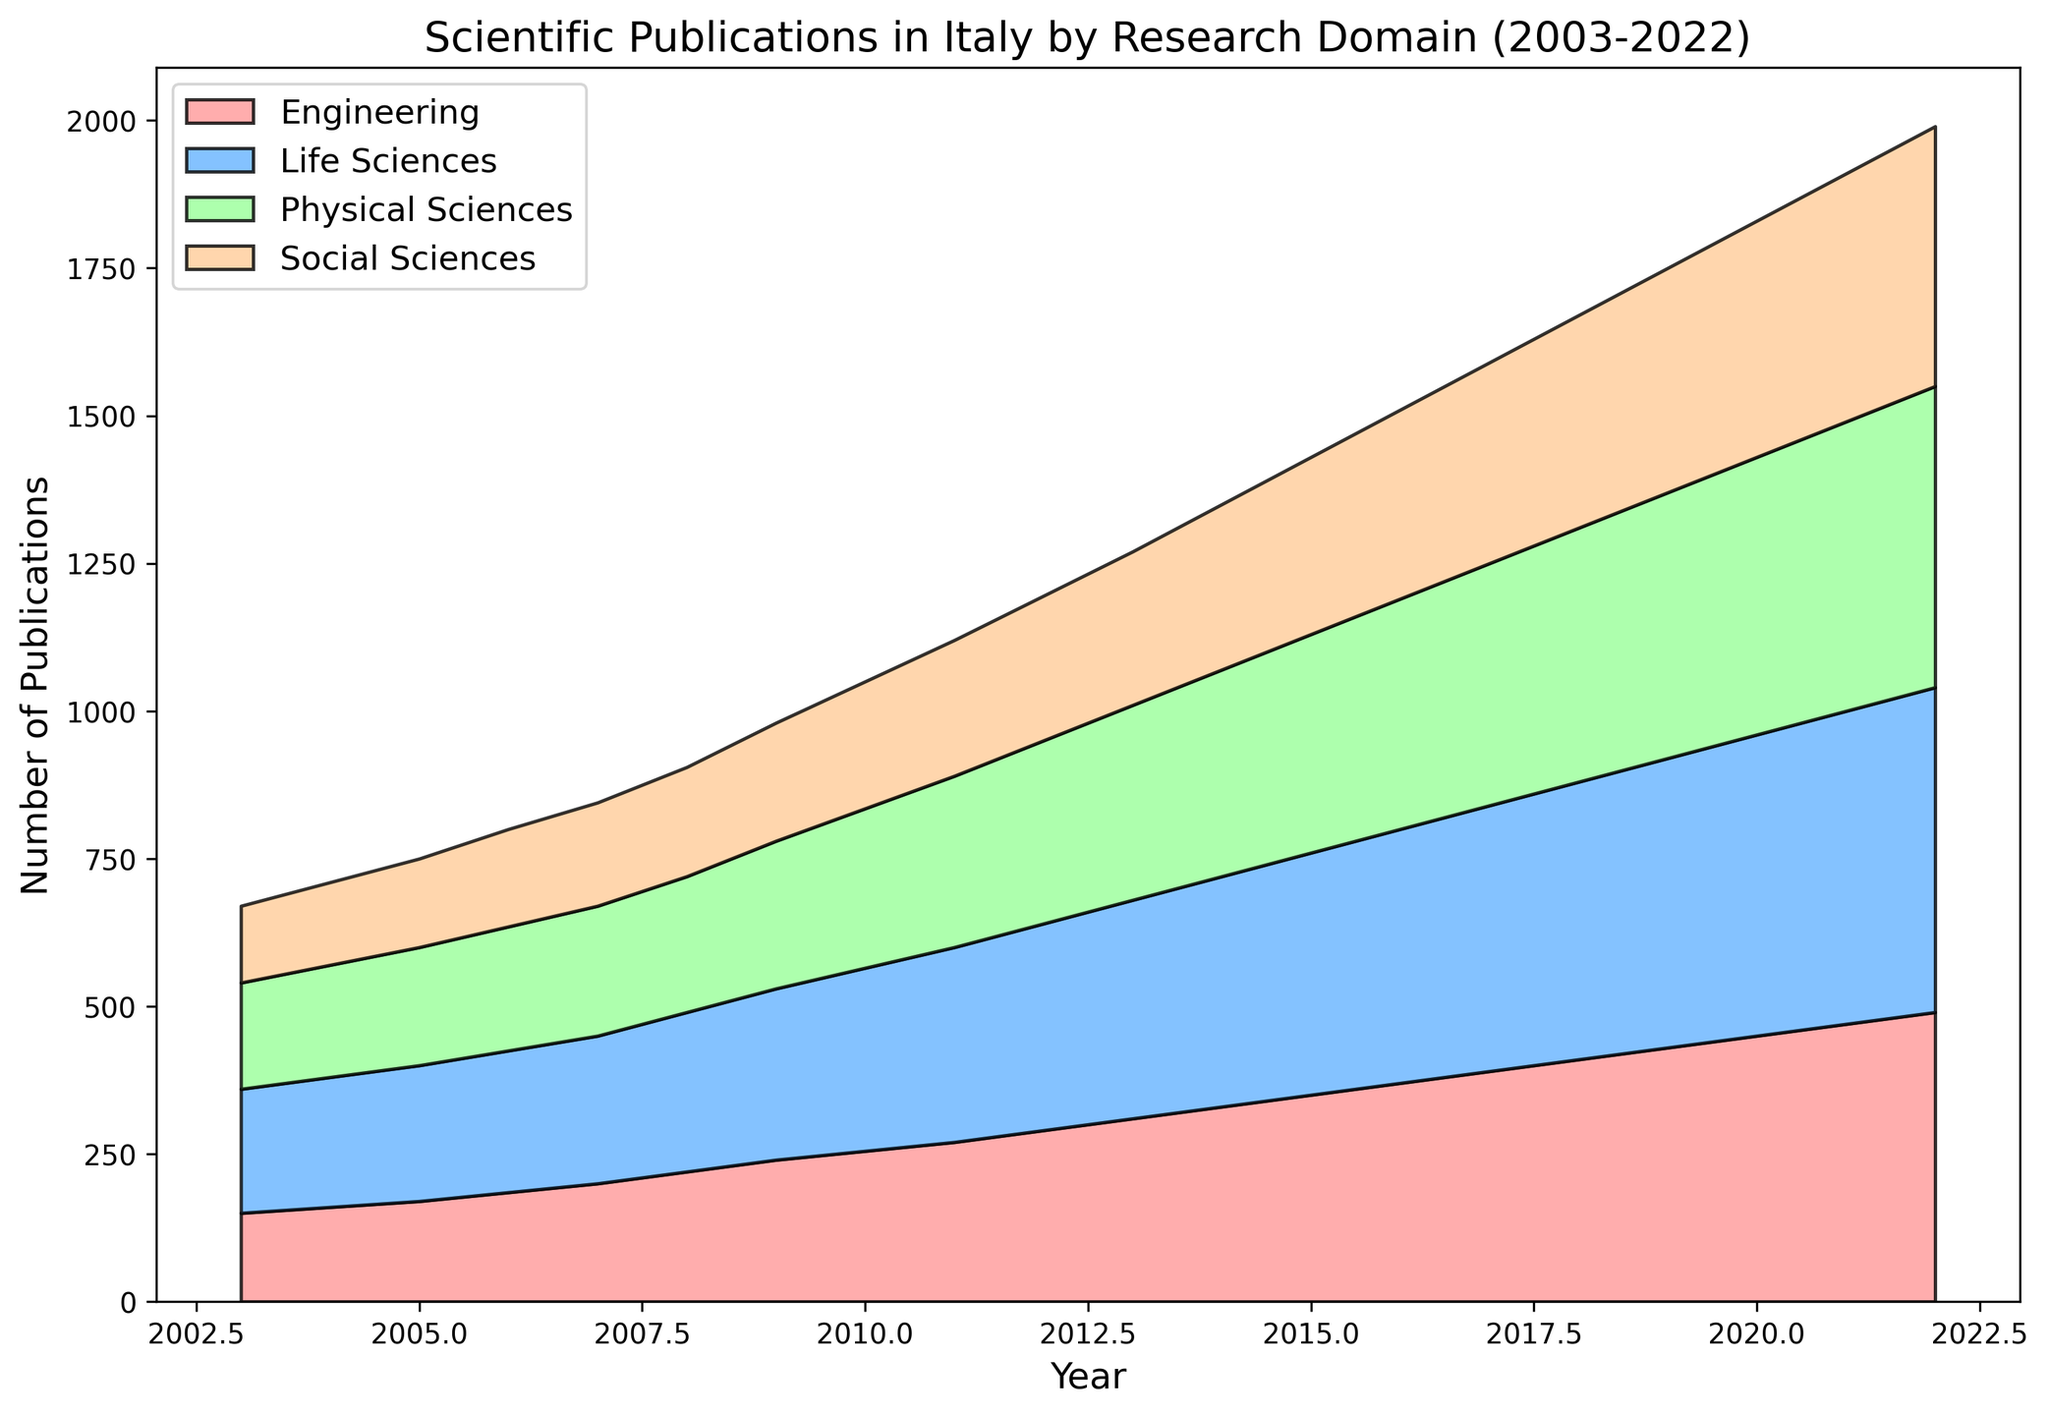What's the trend of the Engineering publications over the 20 years? Engineering publications show a consistent upward trend over the 20 years. From 150 publications in 2003, they steadily increased each year, reaching 490 in 2022.
Answer: Consistent upward trend In which year did Life Sciences publications first exceed 300? First, observe the values associated with Life Sciences in the chart. In 2010, the number of publications is 310, which is the first time it exceeds 300.
Answer: 2010 Comparing 2010 and 2020, which domain had the highest growth in publications? Calculate the difference between 2020 and 2010 for each domain: Engineering (450-255=195), Life Sciences (510-310=200), Physical Sciences (470-270=200), and Social Sciences (400-215=185). Both Life Sciences and Physical Sciences had the highest growth with an increase of 200 publications each.
Answer: Life Sciences and Physical Sciences What is the average number of Social Sciences publications between 2010 and 2015? Extract the number of publications for Social Sciences from 2010 to 2015: [215, 230, 245, 260, 280, 300]. Sum these values: 215 + 230 + 245 + 260 + 280 + 300 = 1530. Divide by the number of years: 1530 / 6 = 255.
Answer: 255 Which year saw the smallest gap between the number of Physical Sciences and Engineering publications? By inspecting the chart, calculate the differences for each year. In 2004, the gap is smallest, with Physical Sciences at 190 and Engineering at 160, resulting in a difference of 30.
Answer: 2004 Which domain had the most significant increase in publications between 2005 and 2006? Calculate the differences between 2006 and 2005 for each domain: Engineering (185-170=15), Life Sciences (240-230=10), Physical Sciences (210-200=10), and Social Sciences (165-150=15). Both Engineering and Social Sciences had the most significant increase of 15 publications each.
Answer: Engineering and Social Sciences In terms of growth rate, which domain showed the highest percentage increase from 2003 to 2022? Calculate the percentage increase for each domain from 2003 to 2022: Engineering ((490-150)/150 * 100) = 226.67%, Life Sciences ((550-210)/210 * 100) = 161.90%, Physical Sciences ((510-180)/180 * 100) = 183.33%, Social Sciences ((440-130)/130 * 100) = 238.46%. The Social Sciences domain had the highest percentage increase.
Answer: Social Sciences By how much did the total number of publications across all domains change from 2003 to 2022? Calculate the total number of publications for all domains in 2003: 150 + 210 + 180 + 130 = 670. In 2022: 490 + 550 + 510 + 440 = 1990. Change in publications = 1990 - 670 = 1320.
Answer: 1320 